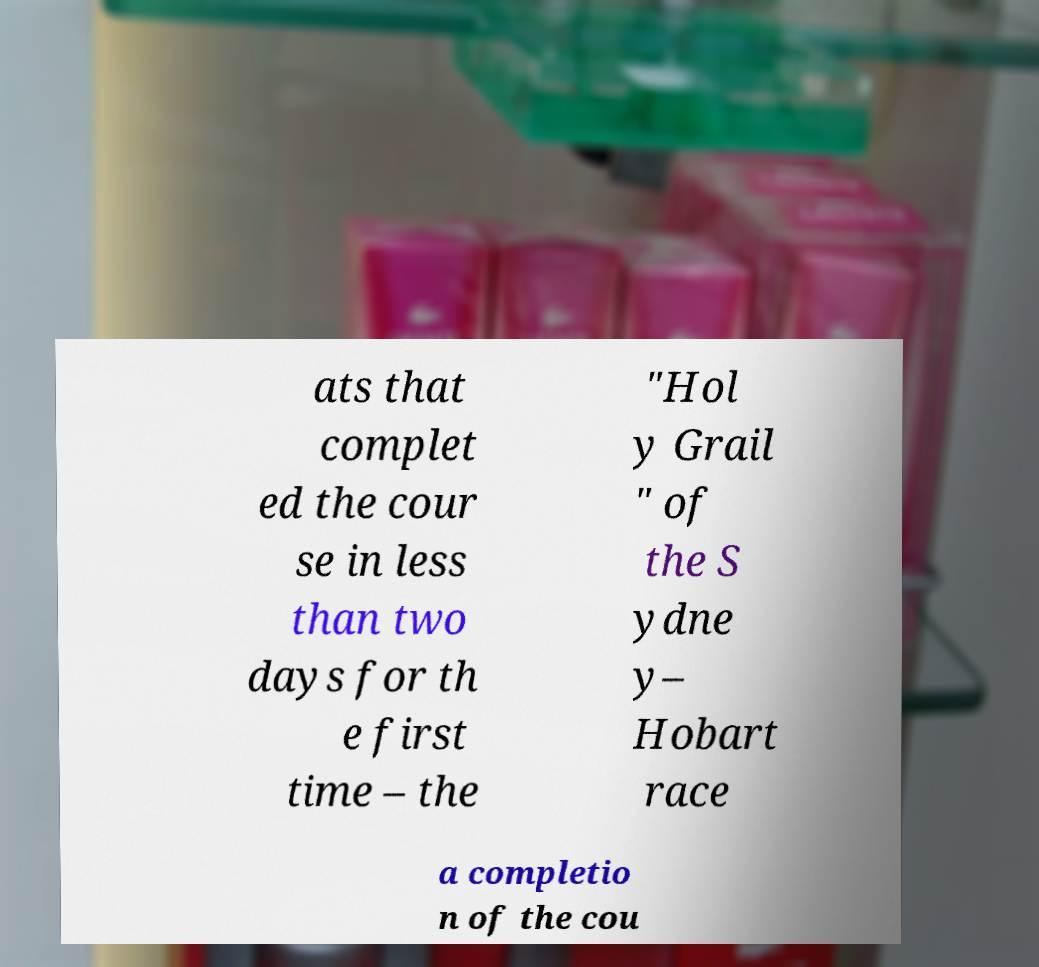For documentation purposes, I need the text within this image transcribed. Could you provide that? ats that complet ed the cour se in less than two days for th e first time – the "Hol y Grail " of the S ydne y– Hobart race a completio n of the cou 